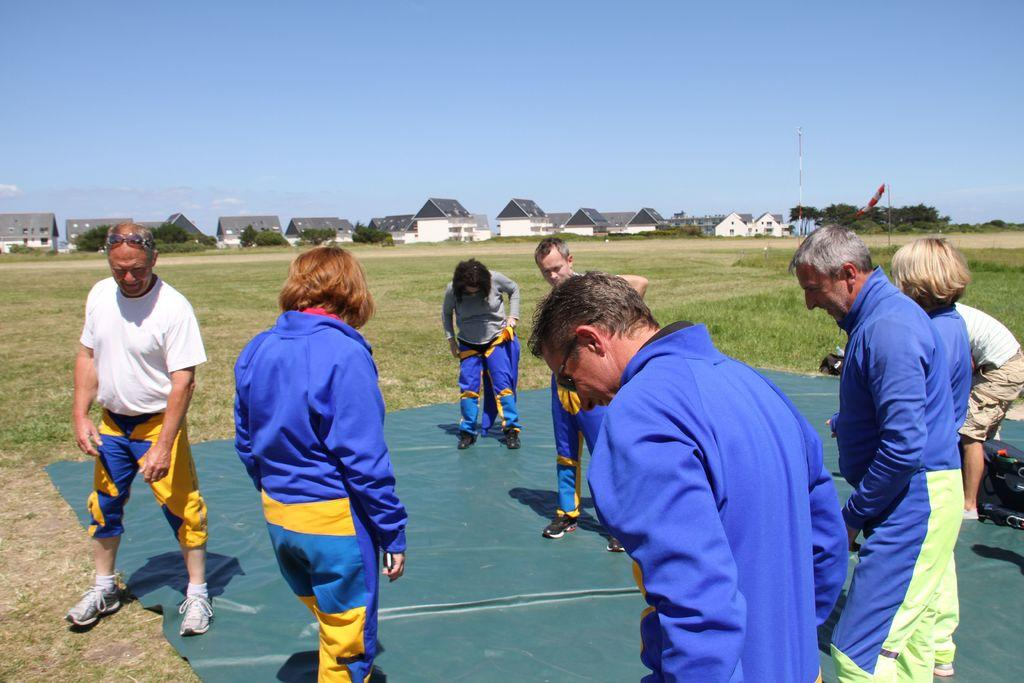What can be seen on the ground in the image? There are people visible on the ground. What structures are located in the middle of the image? There are houses in the middle of the image. What objects are present in the image that are taller than the people? There are poles in the image. What type of vegetation is visible in the image? There are trees in the image. What is visible at the top of the image? The sky is visible at the top of the image. What type of slave is depicted in the image? There is no depiction of a slave in the image; it features people, houses, poles, trees, and the sky. How many sacks of jam are visible in the image? There are no sacks of jam present in the image. 